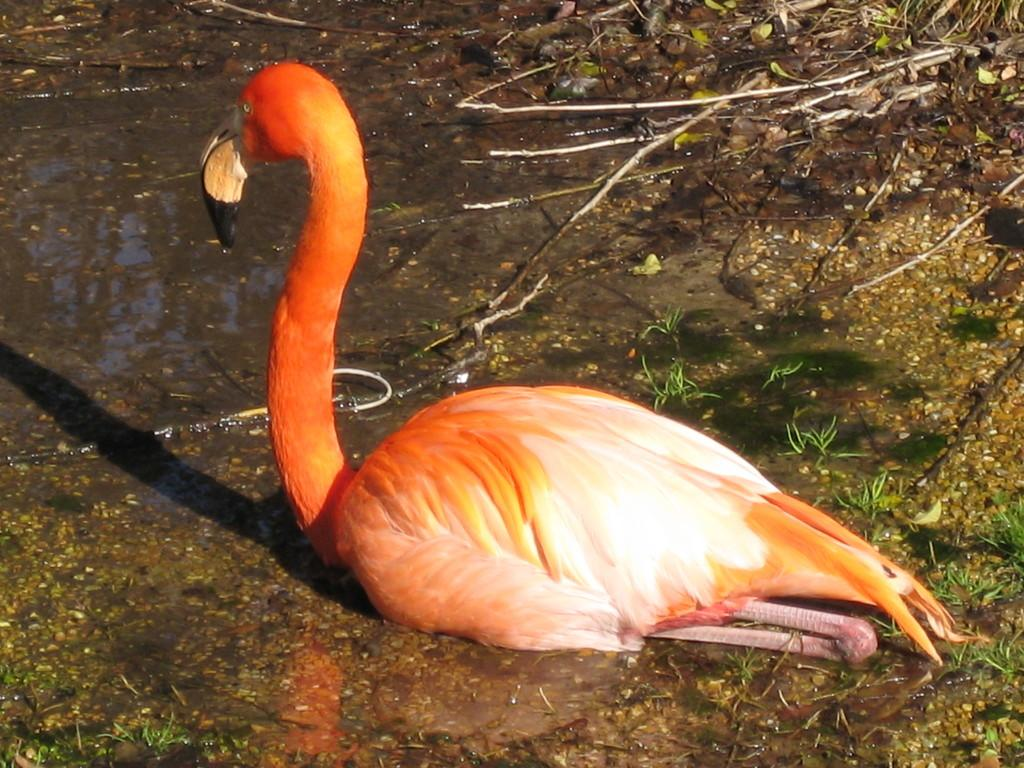What type of bird is in the image? There is a Flamingo bird in the image. Where is the Flamingo bird located? The Flamingo bird is sitting on the muddy water. What other natural elements can be seen in the image? Leaves and grass are visible in the image. What type of pump can be seen in the image? There is no pump present in the image. What is the size of the town in the image? There is no town present in the image. 